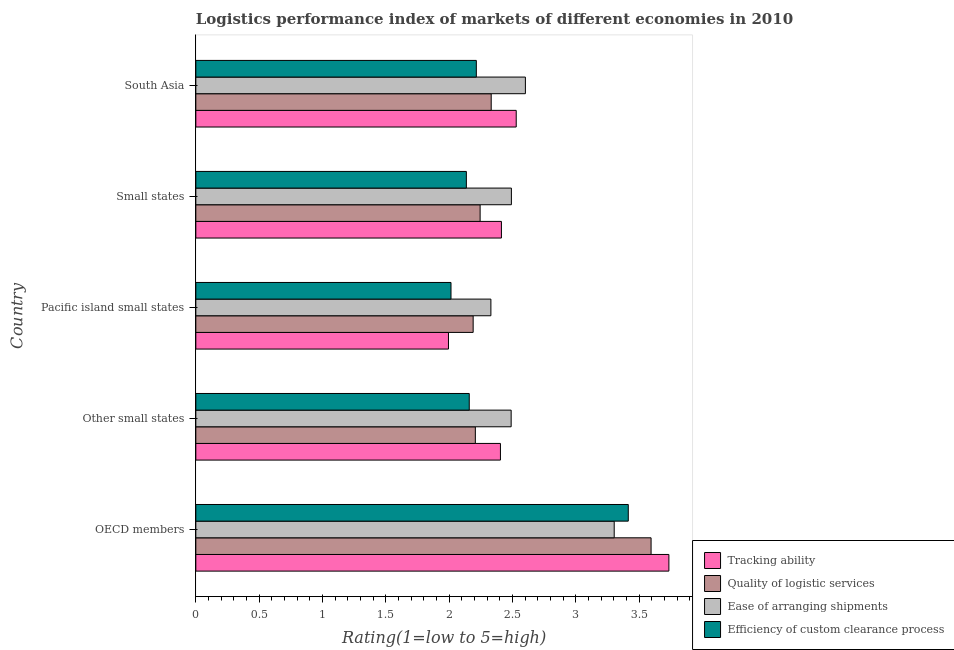How many groups of bars are there?
Your response must be concise. 5. Are the number of bars per tick equal to the number of legend labels?
Your answer should be very brief. Yes. What is the label of the 2nd group of bars from the top?
Give a very brief answer. Small states. What is the lpi rating of tracking ability in Pacific island small states?
Offer a terse response. 2. Across all countries, what is the maximum lpi rating of efficiency of custom clearance process?
Offer a very short reply. 3.42. Across all countries, what is the minimum lpi rating of ease of arranging shipments?
Keep it short and to the point. 2.33. In which country was the lpi rating of ease of arranging shipments maximum?
Keep it short and to the point. OECD members. In which country was the lpi rating of tracking ability minimum?
Offer a very short reply. Pacific island small states. What is the total lpi rating of efficiency of custom clearance process in the graph?
Give a very brief answer. 11.94. What is the difference between the lpi rating of ease of arranging shipments in Small states and that in South Asia?
Your answer should be compact. -0.11. What is the difference between the lpi rating of quality of logistic services in Pacific island small states and the lpi rating of efficiency of custom clearance process in Small states?
Keep it short and to the point. 0.05. What is the average lpi rating of efficiency of custom clearance process per country?
Keep it short and to the point. 2.39. What is the difference between the lpi rating of tracking ability and lpi rating of ease of arranging shipments in Pacific island small states?
Give a very brief answer. -0.34. In how many countries, is the lpi rating of quality of logistic services greater than 2.5 ?
Your answer should be very brief. 1. What is the ratio of the lpi rating of quality of logistic services in Other small states to that in South Asia?
Give a very brief answer. 0.95. Is the lpi rating of tracking ability in Other small states less than that in South Asia?
Your response must be concise. Yes. Is the difference between the lpi rating of tracking ability in Other small states and South Asia greater than the difference between the lpi rating of quality of logistic services in Other small states and South Asia?
Make the answer very short. Yes. What is the difference between the highest and the second highest lpi rating of quality of logistic services?
Provide a short and direct response. 1.26. What is the difference between the highest and the lowest lpi rating of tracking ability?
Offer a terse response. 1.74. In how many countries, is the lpi rating of quality of logistic services greater than the average lpi rating of quality of logistic services taken over all countries?
Give a very brief answer. 1. Is it the case that in every country, the sum of the lpi rating of ease of arranging shipments and lpi rating of tracking ability is greater than the sum of lpi rating of efficiency of custom clearance process and lpi rating of quality of logistic services?
Keep it short and to the point. No. What does the 2nd bar from the top in OECD members represents?
Offer a very short reply. Ease of arranging shipments. What does the 1st bar from the bottom in Other small states represents?
Your answer should be very brief. Tracking ability. Are all the bars in the graph horizontal?
Your answer should be compact. Yes. How many countries are there in the graph?
Keep it short and to the point. 5. What is the difference between two consecutive major ticks on the X-axis?
Make the answer very short. 0.5. Are the values on the major ticks of X-axis written in scientific E-notation?
Provide a succinct answer. No. Does the graph contain any zero values?
Your answer should be very brief. No. How are the legend labels stacked?
Your answer should be very brief. Vertical. What is the title of the graph?
Your answer should be compact. Logistics performance index of markets of different economies in 2010. Does "Rule based governance" appear as one of the legend labels in the graph?
Your answer should be very brief. No. What is the label or title of the X-axis?
Give a very brief answer. Rating(1=low to 5=high). What is the label or title of the Y-axis?
Offer a very short reply. Country. What is the Rating(1=low to 5=high) of Tracking ability in OECD members?
Make the answer very short. 3.74. What is the Rating(1=low to 5=high) of Quality of logistic services in OECD members?
Keep it short and to the point. 3.6. What is the Rating(1=low to 5=high) of Ease of arranging shipments in OECD members?
Offer a terse response. 3.3. What is the Rating(1=low to 5=high) in Efficiency of custom clearance process in OECD members?
Offer a terse response. 3.42. What is the Rating(1=low to 5=high) in Tracking ability in Other small states?
Provide a succinct answer. 2.41. What is the Rating(1=low to 5=high) of Quality of logistic services in Other small states?
Keep it short and to the point. 2.21. What is the Rating(1=low to 5=high) of Ease of arranging shipments in Other small states?
Provide a short and direct response. 2.49. What is the Rating(1=low to 5=high) of Efficiency of custom clearance process in Other small states?
Your answer should be compact. 2.16. What is the Rating(1=low to 5=high) of Tracking ability in Pacific island small states?
Your answer should be compact. 2. What is the Rating(1=low to 5=high) in Quality of logistic services in Pacific island small states?
Offer a very short reply. 2.19. What is the Rating(1=low to 5=high) of Ease of arranging shipments in Pacific island small states?
Offer a terse response. 2.33. What is the Rating(1=low to 5=high) of Efficiency of custom clearance process in Pacific island small states?
Your answer should be compact. 2.02. What is the Rating(1=low to 5=high) in Tracking ability in Small states?
Keep it short and to the point. 2.41. What is the Rating(1=low to 5=high) of Quality of logistic services in Small states?
Your response must be concise. 2.25. What is the Rating(1=low to 5=high) of Ease of arranging shipments in Small states?
Make the answer very short. 2.49. What is the Rating(1=low to 5=high) of Efficiency of custom clearance process in Small states?
Provide a succinct answer. 2.14. What is the Rating(1=low to 5=high) in Tracking ability in South Asia?
Your answer should be very brief. 2.53. What is the Rating(1=low to 5=high) of Quality of logistic services in South Asia?
Provide a short and direct response. 2.33. What is the Rating(1=low to 5=high) of Ease of arranging shipments in South Asia?
Give a very brief answer. 2.6. What is the Rating(1=low to 5=high) in Efficiency of custom clearance process in South Asia?
Offer a terse response. 2.21. Across all countries, what is the maximum Rating(1=low to 5=high) of Tracking ability?
Make the answer very short. 3.74. Across all countries, what is the maximum Rating(1=low to 5=high) in Quality of logistic services?
Keep it short and to the point. 3.6. Across all countries, what is the maximum Rating(1=low to 5=high) of Ease of arranging shipments?
Your answer should be very brief. 3.3. Across all countries, what is the maximum Rating(1=low to 5=high) in Efficiency of custom clearance process?
Your answer should be compact. 3.42. Across all countries, what is the minimum Rating(1=low to 5=high) in Tracking ability?
Ensure brevity in your answer.  2. Across all countries, what is the minimum Rating(1=low to 5=high) of Quality of logistic services?
Your answer should be very brief. 2.19. Across all countries, what is the minimum Rating(1=low to 5=high) of Ease of arranging shipments?
Provide a short and direct response. 2.33. Across all countries, what is the minimum Rating(1=low to 5=high) in Efficiency of custom clearance process?
Your response must be concise. 2.02. What is the total Rating(1=low to 5=high) in Tracking ability in the graph?
Keep it short and to the point. 13.08. What is the total Rating(1=low to 5=high) in Quality of logistic services in the graph?
Offer a very short reply. 12.57. What is the total Rating(1=low to 5=high) of Ease of arranging shipments in the graph?
Your response must be concise. 13.22. What is the total Rating(1=low to 5=high) in Efficiency of custom clearance process in the graph?
Keep it short and to the point. 11.94. What is the difference between the Rating(1=low to 5=high) of Tracking ability in OECD members and that in Other small states?
Ensure brevity in your answer.  1.33. What is the difference between the Rating(1=low to 5=high) in Quality of logistic services in OECD members and that in Other small states?
Provide a short and direct response. 1.39. What is the difference between the Rating(1=low to 5=high) in Ease of arranging shipments in OECD members and that in Other small states?
Provide a succinct answer. 0.81. What is the difference between the Rating(1=low to 5=high) of Efficiency of custom clearance process in OECD members and that in Other small states?
Ensure brevity in your answer.  1.26. What is the difference between the Rating(1=low to 5=high) in Tracking ability in OECD members and that in Pacific island small states?
Provide a succinct answer. 1.74. What is the difference between the Rating(1=low to 5=high) in Quality of logistic services in OECD members and that in Pacific island small states?
Your answer should be compact. 1.41. What is the difference between the Rating(1=low to 5=high) of Ease of arranging shipments in OECD members and that in Pacific island small states?
Offer a very short reply. 0.97. What is the difference between the Rating(1=low to 5=high) of Tracking ability in OECD members and that in Small states?
Ensure brevity in your answer.  1.32. What is the difference between the Rating(1=low to 5=high) of Quality of logistic services in OECD members and that in Small states?
Your answer should be very brief. 1.35. What is the difference between the Rating(1=low to 5=high) in Ease of arranging shipments in OECD members and that in Small states?
Make the answer very short. 0.81. What is the difference between the Rating(1=low to 5=high) in Efficiency of custom clearance process in OECD members and that in Small states?
Give a very brief answer. 1.28. What is the difference between the Rating(1=low to 5=high) of Tracking ability in OECD members and that in South Asia?
Make the answer very short. 1.21. What is the difference between the Rating(1=low to 5=high) in Quality of logistic services in OECD members and that in South Asia?
Your answer should be very brief. 1.26. What is the difference between the Rating(1=low to 5=high) of Ease of arranging shipments in OECD members and that in South Asia?
Make the answer very short. 0.7. What is the difference between the Rating(1=low to 5=high) of Tracking ability in Other small states and that in Pacific island small states?
Offer a very short reply. 0.41. What is the difference between the Rating(1=low to 5=high) of Quality of logistic services in Other small states and that in Pacific island small states?
Offer a very short reply. 0.02. What is the difference between the Rating(1=low to 5=high) in Ease of arranging shipments in Other small states and that in Pacific island small states?
Provide a succinct answer. 0.16. What is the difference between the Rating(1=low to 5=high) in Efficiency of custom clearance process in Other small states and that in Pacific island small states?
Provide a short and direct response. 0.14. What is the difference between the Rating(1=low to 5=high) of Tracking ability in Other small states and that in Small states?
Offer a very short reply. -0.01. What is the difference between the Rating(1=low to 5=high) of Quality of logistic services in Other small states and that in Small states?
Provide a succinct answer. -0.04. What is the difference between the Rating(1=low to 5=high) of Ease of arranging shipments in Other small states and that in Small states?
Give a very brief answer. -0. What is the difference between the Rating(1=low to 5=high) in Efficiency of custom clearance process in Other small states and that in Small states?
Your answer should be very brief. 0.02. What is the difference between the Rating(1=low to 5=high) in Tracking ability in Other small states and that in South Asia?
Your response must be concise. -0.12. What is the difference between the Rating(1=low to 5=high) in Quality of logistic services in Other small states and that in South Asia?
Your answer should be very brief. -0.13. What is the difference between the Rating(1=low to 5=high) of Ease of arranging shipments in Other small states and that in South Asia?
Give a very brief answer. -0.11. What is the difference between the Rating(1=low to 5=high) in Efficiency of custom clearance process in Other small states and that in South Asia?
Your answer should be compact. -0.06. What is the difference between the Rating(1=low to 5=high) of Tracking ability in Pacific island small states and that in Small states?
Make the answer very short. -0.42. What is the difference between the Rating(1=low to 5=high) in Quality of logistic services in Pacific island small states and that in Small states?
Your response must be concise. -0.06. What is the difference between the Rating(1=low to 5=high) of Ease of arranging shipments in Pacific island small states and that in Small states?
Keep it short and to the point. -0.16. What is the difference between the Rating(1=low to 5=high) of Efficiency of custom clearance process in Pacific island small states and that in Small states?
Ensure brevity in your answer.  -0.12. What is the difference between the Rating(1=low to 5=high) of Tracking ability in Pacific island small states and that in South Asia?
Provide a short and direct response. -0.54. What is the difference between the Rating(1=low to 5=high) of Quality of logistic services in Pacific island small states and that in South Asia?
Your answer should be very brief. -0.14. What is the difference between the Rating(1=low to 5=high) of Ease of arranging shipments in Pacific island small states and that in South Asia?
Keep it short and to the point. -0.27. What is the difference between the Rating(1=low to 5=high) in Tracking ability in Small states and that in South Asia?
Provide a short and direct response. -0.12. What is the difference between the Rating(1=low to 5=high) of Quality of logistic services in Small states and that in South Asia?
Keep it short and to the point. -0.09. What is the difference between the Rating(1=low to 5=high) of Ease of arranging shipments in Small states and that in South Asia?
Your answer should be very brief. -0.11. What is the difference between the Rating(1=low to 5=high) of Efficiency of custom clearance process in Small states and that in South Asia?
Give a very brief answer. -0.08. What is the difference between the Rating(1=low to 5=high) in Tracking ability in OECD members and the Rating(1=low to 5=high) in Quality of logistic services in Other small states?
Your answer should be compact. 1.53. What is the difference between the Rating(1=low to 5=high) of Tracking ability in OECD members and the Rating(1=low to 5=high) of Ease of arranging shipments in Other small states?
Give a very brief answer. 1.25. What is the difference between the Rating(1=low to 5=high) of Tracking ability in OECD members and the Rating(1=low to 5=high) of Efficiency of custom clearance process in Other small states?
Make the answer very short. 1.58. What is the difference between the Rating(1=low to 5=high) of Quality of logistic services in OECD members and the Rating(1=low to 5=high) of Ease of arranging shipments in Other small states?
Provide a short and direct response. 1.1. What is the difference between the Rating(1=low to 5=high) of Quality of logistic services in OECD members and the Rating(1=low to 5=high) of Efficiency of custom clearance process in Other small states?
Offer a very short reply. 1.44. What is the difference between the Rating(1=low to 5=high) of Ease of arranging shipments in OECD members and the Rating(1=low to 5=high) of Efficiency of custom clearance process in Other small states?
Offer a terse response. 1.14. What is the difference between the Rating(1=low to 5=high) of Tracking ability in OECD members and the Rating(1=low to 5=high) of Quality of logistic services in Pacific island small states?
Your response must be concise. 1.55. What is the difference between the Rating(1=low to 5=high) in Tracking ability in OECD members and the Rating(1=low to 5=high) in Ease of arranging shipments in Pacific island small states?
Provide a short and direct response. 1.41. What is the difference between the Rating(1=low to 5=high) of Tracking ability in OECD members and the Rating(1=low to 5=high) of Efficiency of custom clearance process in Pacific island small states?
Your answer should be very brief. 1.72. What is the difference between the Rating(1=low to 5=high) in Quality of logistic services in OECD members and the Rating(1=low to 5=high) in Ease of arranging shipments in Pacific island small states?
Your response must be concise. 1.26. What is the difference between the Rating(1=low to 5=high) of Quality of logistic services in OECD members and the Rating(1=low to 5=high) of Efficiency of custom clearance process in Pacific island small states?
Your answer should be very brief. 1.58. What is the difference between the Rating(1=low to 5=high) in Ease of arranging shipments in OECD members and the Rating(1=low to 5=high) in Efficiency of custom clearance process in Pacific island small states?
Provide a succinct answer. 1.29. What is the difference between the Rating(1=low to 5=high) in Tracking ability in OECD members and the Rating(1=low to 5=high) in Quality of logistic services in Small states?
Your response must be concise. 1.49. What is the difference between the Rating(1=low to 5=high) in Tracking ability in OECD members and the Rating(1=low to 5=high) in Ease of arranging shipments in Small states?
Ensure brevity in your answer.  1.24. What is the difference between the Rating(1=low to 5=high) in Tracking ability in OECD members and the Rating(1=low to 5=high) in Efficiency of custom clearance process in Small states?
Your answer should be compact. 1.6. What is the difference between the Rating(1=low to 5=high) of Quality of logistic services in OECD members and the Rating(1=low to 5=high) of Ease of arranging shipments in Small states?
Keep it short and to the point. 1.1. What is the difference between the Rating(1=low to 5=high) of Quality of logistic services in OECD members and the Rating(1=low to 5=high) of Efficiency of custom clearance process in Small states?
Offer a very short reply. 1.46. What is the difference between the Rating(1=low to 5=high) of Ease of arranging shipments in OECD members and the Rating(1=low to 5=high) of Efficiency of custom clearance process in Small states?
Provide a succinct answer. 1.17. What is the difference between the Rating(1=low to 5=high) of Tracking ability in OECD members and the Rating(1=low to 5=high) of Quality of logistic services in South Asia?
Ensure brevity in your answer.  1.4. What is the difference between the Rating(1=low to 5=high) in Tracking ability in OECD members and the Rating(1=low to 5=high) in Ease of arranging shipments in South Asia?
Offer a very short reply. 1.13. What is the difference between the Rating(1=low to 5=high) in Tracking ability in OECD members and the Rating(1=low to 5=high) in Efficiency of custom clearance process in South Asia?
Your response must be concise. 1.52. What is the difference between the Rating(1=low to 5=high) of Quality of logistic services in OECD members and the Rating(1=low to 5=high) of Efficiency of custom clearance process in South Asia?
Offer a very short reply. 1.38. What is the difference between the Rating(1=low to 5=high) in Ease of arranging shipments in OECD members and the Rating(1=low to 5=high) in Efficiency of custom clearance process in South Asia?
Offer a terse response. 1.09. What is the difference between the Rating(1=low to 5=high) in Tracking ability in Other small states and the Rating(1=low to 5=high) in Quality of logistic services in Pacific island small states?
Keep it short and to the point. 0.22. What is the difference between the Rating(1=low to 5=high) in Tracking ability in Other small states and the Rating(1=low to 5=high) in Ease of arranging shipments in Pacific island small states?
Your response must be concise. 0.08. What is the difference between the Rating(1=low to 5=high) in Tracking ability in Other small states and the Rating(1=low to 5=high) in Efficiency of custom clearance process in Pacific island small states?
Offer a terse response. 0.39. What is the difference between the Rating(1=low to 5=high) of Quality of logistic services in Other small states and the Rating(1=low to 5=high) of Ease of arranging shipments in Pacific island small states?
Your response must be concise. -0.12. What is the difference between the Rating(1=low to 5=high) of Quality of logistic services in Other small states and the Rating(1=low to 5=high) of Efficiency of custom clearance process in Pacific island small states?
Make the answer very short. 0.19. What is the difference between the Rating(1=low to 5=high) in Ease of arranging shipments in Other small states and the Rating(1=low to 5=high) in Efficiency of custom clearance process in Pacific island small states?
Provide a short and direct response. 0.47. What is the difference between the Rating(1=low to 5=high) of Tracking ability in Other small states and the Rating(1=low to 5=high) of Quality of logistic services in Small states?
Give a very brief answer. 0.16. What is the difference between the Rating(1=low to 5=high) in Tracking ability in Other small states and the Rating(1=low to 5=high) in Ease of arranging shipments in Small states?
Your answer should be compact. -0.09. What is the difference between the Rating(1=low to 5=high) in Tracking ability in Other small states and the Rating(1=low to 5=high) in Efficiency of custom clearance process in Small states?
Keep it short and to the point. 0.27. What is the difference between the Rating(1=low to 5=high) of Quality of logistic services in Other small states and the Rating(1=low to 5=high) of Ease of arranging shipments in Small states?
Provide a short and direct response. -0.28. What is the difference between the Rating(1=low to 5=high) in Quality of logistic services in Other small states and the Rating(1=low to 5=high) in Efficiency of custom clearance process in Small states?
Provide a succinct answer. 0.07. What is the difference between the Rating(1=low to 5=high) of Ease of arranging shipments in Other small states and the Rating(1=low to 5=high) of Efficiency of custom clearance process in Small states?
Make the answer very short. 0.35. What is the difference between the Rating(1=low to 5=high) of Tracking ability in Other small states and the Rating(1=low to 5=high) of Quality of logistic services in South Asia?
Offer a very short reply. 0.07. What is the difference between the Rating(1=low to 5=high) of Tracking ability in Other small states and the Rating(1=low to 5=high) of Ease of arranging shipments in South Asia?
Ensure brevity in your answer.  -0.2. What is the difference between the Rating(1=low to 5=high) in Tracking ability in Other small states and the Rating(1=low to 5=high) in Efficiency of custom clearance process in South Asia?
Provide a short and direct response. 0.19. What is the difference between the Rating(1=low to 5=high) in Quality of logistic services in Other small states and the Rating(1=low to 5=high) in Ease of arranging shipments in South Asia?
Your response must be concise. -0.4. What is the difference between the Rating(1=low to 5=high) in Quality of logistic services in Other small states and the Rating(1=low to 5=high) in Efficiency of custom clearance process in South Asia?
Give a very brief answer. -0.01. What is the difference between the Rating(1=low to 5=high) in Ease of arranging shipments in Other small states and the Rating(1=low to 5=high) in Efficiency of custom clearance process in South Asia?
Keep it short and to the point. 0.28. What is the difference between the Rating(1=low to 5=high) in Tracking ability in Pacific island small states and the Rating(1=low to 5=high) in Ease of arranging shipments in Small states?
Your answer should be compact. -0.5. What is the difference between the Rating(1=low to 5=high) of Tracking ability in Pacific island small states and the Rating(1=low to 5=high) of Efficiency of custom clearance process in Small states?
Offer a terse response. -0.14. What is the difference between the Rating(1=low to 5=high) in Quality of logistic services in Pacific island small states and the Rating(1=low to 5=high) in Ease of arranging shipments in Small states?
Offer a terse response. -0.3. What is the difference between the Rating(1=low to 5=high) in Quality of logistic services in Pacific island small states and the Rating(1=low to 5=high) in Efficiency of custom clearance process in Small states?
Provide a short and direct response. 0.05. What is the difference between the Rating(1=low to 5=high) in Ease of arranging shipments in Pacific island small states and the Rating(1=low to 5=high) in Efficiency of custom clearance process in Small states?
Provide a short and direct response. 0.19. What is the difference between the Rating(1=low to 5=high) of Tracking ability in Pacific island small states and the Rating(1=low to 5=high) of Quality of logistic services in South Asia?
Give a very brief answer. -0.34. What is the difference between the Rating(1=low to 5=high) in Tracking ability in Pacific island small states and the Rating(1=low to 5=high) in Ease of arranging shipments in South Asia?
Your answer should be very brief. -0.61. What is the difference between the Rating(1=low to 5=high) in Tracking ability in Pacific island small states and the Rating(1=low to 5=high) in Efficiency of custom clearance process in South Asia?
Your answer should be compact. -0.22. What is the difference between the Rating(1=low to 5=high) of Quality of logistic services in Pacific island small states and the Rating(1=low to 5=high) of Ease of arranging shipments in South Asia?
Your answer should be compact. -0.41. What is the difference between the Rating(1=low to 5=high) of Quality of logistic services in Pacific island small states and the Rating(1=low to 5=high) of Efficiency of custom clearance process in South Asia?
Offer a terse response. -0.03. What is the difference between the Rating(1=low to 5=high) of Ease of arranging shipments in Pacific island small states and the Rating(1=low to 5=high) of Efficiency of custom clearance process in South Asia?
Keep it short and to the point. 0.12. What is the difference between the Rating(1=low to 5=high) in Tracking ability in Small states and the Rating(1=low to 5=high) in Quality of logistic services in South Asia?
Your answer should be compact. 0.08. What is the difference between the Rating(1=low to 5=high) in Tracking ability in Small states and the Rating(1=low to 5=high) in Ease of arranging shipments in South Asia?
Offer a very short reply. -0.19. What is the difference between the Rating(1=low to 5=high) in Tracking ability in Small states and the Rating(1=low to 5=high) in Efficiency of custom clearance process in South Asia?
Keep it short and to the point. 0.2. What is the difference between the Rating(1=low to 5=high) of Quality of logistic services in Small states and the Rating(1=low to 5=high) of Ease of arranging shipments in South Asia?
Give a very brief answer. -0.36. What is the difference between the Rating(1=low to 5=high) in Quality of logistic services in Small states and the Rating(1=low to 5=high) in Efficiency of custom clearance process in South Asia?
Offer a very short reply. 0.03. What is the difference between the Rating(1=low to 5=high) in Ease of arranging shipments in Small states and the Rating(1=low to 5=high) in Efficiency of custom clearance process in South Asia?
Give a very brief answer. 0.28. What is the average Rating(1=low to 5=high) of Tracking ability per country?
Make the answer very short. 2.62. What is the average Rating(1=low to 5=high) in Quality of logistic services per country?
Provide a short and direct response. 2.51. What is the average Rating(1=low to 5=high) of Ease of arranging shipments per country?
Your answer should be very brief. 2.64. What is the average Rating(1=low to 5=high) in Efficiency of custom clearance process per country?
Offer a very short reply. 2.39. What is the difference between the Rating(1=low to 5=high) of Tracking ability and Rating(1=low to 5=high) of Quality of logistic services in OECD members?
Provide a short and direct response. 0.14. What is the difference between the Rating(1=low to 5=high) in Tracking ability and Rating(1=low to 5=high) in Ease of arranging shipments in OECD members?
Give a very brief answer. 0.43. What is the difference between the Rating(1=low to 5=high) in Tracking ability and Rating(1=low to 5=high) in Efficiency of custom clearance process in OECD members?
Offer a terse response. 0.32. What is the difference between the Rating(1=low to 5=high) in Quality of logistic services and Rating(1=low to 5=high) in Ease of arranging shipments in OECD members?
Your response must be concise. 0.29. What is the difference between the Rating(1=low to 5=high) in Quality of logistic services and Rating(1=low to 5=high) in Efficiency of custom clearance process in OECD members?
Your answer should be compact. 0.18. What is the difference between the Rating(1=low to 5=high) in Ease of arranging shipments and Rating(1=low to 5=high) in Efficiency of custom clearance process in OECD members?
Provide a short and direct response. -0.11. What is the difference between the Rating(1=low to 5=high) of Tracking ability and Rating(1=low to 5=high) of Quality of logistic services in Other small states?
Ensure brevity in your answer.  0.2. What is the difference between the Rating(1=low to 5=high) of Tracking ability and Rating(1=low to 5=high) of Ease of arranging shipments in Other small states?
Your response must be concise. -0.08. What is the difference between the Rating(1=low to 5=high) of Tracking ability and Rating(1=low to 5=high) of Efficiency of custom clearance process in Other small states?
Give a very brief answer. 0.25. What is the difference between the Rating(1=low to 5=high) in Quality of logistic services and Rating(1=low to 5=high) in Ease of arranging shipments in Other small states?
Give a very brief answer. -0.28. What is the difference between the Rating(1=low to 5=high) of Quality of logistic services and Rating(1=low to 5=high) of Efficiency of custom clearance process in Other small states?
Provide a short and direct response. 0.05. What is the difference between the Rating(1=low to 5=high) in Ease of arranging shipments and Rating(1=low to 5=high) in Efficiency of custom clearance process in Other small states?
Provide a succinct answer. 0.33. What is the difference between the Rating(1=low to 5=high) in Tracking ability and Rating(1=low to 5=high) in Quality of logistic services in Pacific island small states?
Offer a terse response. -0.2. What is the difference between the Rating(1=low to 5=high) in Tracking ability and Rating(1=low to 5=high) in Ease of arranging shipments in Pacific island small states?
Ensure brevity in your answer.  -0.34. What is the difference between the Rating(1=low to 5=high) in Tracking ability and Rating(1=low to 5=high) in Efficiency of custom clearance process in Pacific island small states?
Give a very brief answer. -0.02. What is the difference between the Rating(1=low to 5=high) of Quality of logistic services and Rating(1=low to 5=high) of Ease of arranging shipments in Pacific island small states?
Your response must be concise. -0.14. What is the difference between the Rating(1=low to 5=high) of Quality of logistic services and Rating(1=low to 5=high) of Efficiency of custom clearance process in Pacific island small states?
Offer a terse response. 0.17. What is the difference between the Rating(1=low to 5=high) of Ease of arranging shipments and Rating(1=low to 5=high) of Efficiency of custom clearance process in Pacific island small states?
Give a very brief answer. 0.32. What is the difference between the Rating(1=low to 5=high) of Tracking ability and Rating(1=low to 5=high) of Quality of logistic services in Small states?
Keep it short and to the point. 0.17. What is the difference between the Rating(1=low to 5=high) of Tracking ability and Rating(1=low to 5=high) of Ease of arranging shipments in Small states?
Keep it short and to the point. -0.08. What is the difference between the Rating(1=low to 5=high) in Tracking ability and Rating(1=low to 5=high) in Efficiency of custom clearance process in Small states?
Offer a terse response. 0.28. What is the difference between the Rating(1=low to 5=high) of Quality of logistic services and Rating(1=low to 5=high) of Ease of arranging shipments in Small states?
Keep it short and to the point. -0.25. What is the difference between the Rating(1=low to 5=high) of Quality of logistic services and Rating(1=low to 5=high) of Efficiency of custom clearance process in Small states?
Offer a very short reply. 0.11. What is the difference between the Rating(1=low to 5=high) of Ease of arranging shipments and Rating(1=low to 5=high) of Efficiency of custom clearance process in Small states?
Your answer should be compact. 0.36. What is the difference between the Rating(1=low to 5=high) of Tracking ability and Rating(1=low to 5=high) of Quality of logistic services in South Asia?
Keep it short and to the point. 0.2. What is the difference between the Rating(1=low to 5=high) in Tracking ability and Rating(1=low to 5=high) in Ease of arranging shipments in South Asia?
Keep it short and to the point. -0.07. What is the difference between the Rating(1=low to 5=high) of Tracking ability and Rating(1=low to 5=high) of Efficiency of custom clearance process in South Asia?
Your answer should be very brief. 0.32. What is the difference between the Rating(1=low to 5=high) in Quality of logistic services and Rating(1=low to 5=high) in Ease of arranging shipments in South Asia?
Provide a succinct answer. -0.27. What is the difference between the Rating(1=low to 5=high) in Quality of logistic services and Rating(1=low to 5=high) in Efficiency of custom clearance process in South Asia?
Keep it short and to the point. 0.12. What is the difference between the Rating(1=low to 5=high) of Ease of arranging shipments and Rating(1=low to 5=high) of Efficiency of custom clearance process in South Asia?
Provide a short and direct response. 0.39. What is the ratio of the Rating(1=low to 5=high) in Tracking ability in OECD members to that in Other small states?
Ensure brevity in your answer.  1.55. What is the ratio of the Rating(1=low to 5=high) of Quality of logistic services in OECD members to that in Other small states?
Offer a very short reply. 1.63. What is the ratio of the Rating(1=low to 5=high) of Ease of arranging shipments in OECD members to that in Other small states?
Provide a succinct answer. 1.33. What is the ratio of the Rating(1=low to 5=high) of Efficiency of custom clearance process in OECD members to that in Other small states?
Make the answer very short. 1.58. What is the ratio of the Rating(1=low to 5=high) of Tracking ability in OECD members to that in Pacific island small states?
Your answer should be compact. 1.87. What is the ratio of the Rating(1=low to 5=high) of Quality of logistic services in OECD members to that in Pacific island small states?
Keep it short and to the point. 1.64. What is the ratio of the Rating(1=low to 5=high) in Ease of arranging shipments in OECD members to that in Pacific island small states?
Your answer should be very brief. 1.42. What is the ratio of the Rating(1=low to 5=high) in Efficiency of custom clearance process in OECD members to that in Pacific island small states?
Give a very brief answer. 1.69. What is the ratio of the Rating(1=low to 5=high) of Tracking ability in OECD members to that in Small states?
Give a very brief answer. 1.55. What is the ratio of the Rating(1=low to 5=high) of Quality of logistic services in OECD members to that in Small states?
Provide a succinct answer. 1.6. What is the ratio of the Rating(1=low to 5=high) of Ease of arranging shipments in OECD members to that in Small states?
Offer a terse response. 1.33. What is the ratio of the Rating(1=low to 5=high) in Efficiency of custom clearance process in OECD members to that in Small states?
Offer a terse response. 1.6. What is the ratio of the Rating(1=low to 5=high) of Tracking ability in OECD members to that in South Asia?
Ensure brevity in your answer.  1.48. What is the ratio of the Rating(1=low to 5=high) of Quality of logistic services in OECD members to that in South Asia?
Make the answer very short. 1.54. What is the ratio of the Rating(1=low to 5=high) of Ease of arranging shipments in OECD members to that in South Asia?
Provide a succinct answer. 1.27. What is the ratio of the Rating(1=low to 5=high) of Efficiency of custom clearance process in OECD members to that in South Asia?
Provide a succinct answer. 1.54. What is the ratio of the Rating(1=low to 5=high) in Tracking ability in Other small states to that in Pacific island small states?
Provide a short and direct response. 1.21. What is the ratio of the Rating(1=low to 5=high) of Quality of logistic services in Other small states to that in Pacific island small states?
Keep it short and to the point. 1.01. What is the ratio of the Rating(1=low to 5=high) in Ease of arranging shipments in Other small states to that in Pacific island small states?
Your response must be concise. 1.07. What is the ratio of the Rating(1=low to 5=high) in Efficiency of custom clearance process in Other small states to that in Pacific island small states?
Give a very brief answer. 1.07. What is the ratio of the Rating(1=low to 5=high) in Tracking ability in Other small states to that in Small states?
Offer a terse response. 1. What is the ratio of the Rating(1=low to 5=high) of Quality of logistic services in Other small states to that in Small states?
Your response must be concise. 0.98. What is the ratio of the Rating(1=low to 5=high) of Efficiency of custom clearance process in Other small states to that in Small states?
Keep it short and to the point. 1.01. What is the ratio of the Rating(1=low to 5=high) of Tracking ability in Other small states to that in South Asia?
Give a very brief answer. 0.95. What is the ratio of the Rating(1=low to 5=high) in Quality of logistic services in Other small states to that in South Asia?
Your response must be concise. 0.95. What is the ratio of the Rating(1=low to 5=high) of Ease of arranging shipments in Other small states to that in South Asia?
Offer a very short reply. 0.96. What is the ratio of the Rating(1=low to 5=high) of Efficiency of custom clearance process in Other small states to that in South Asia?
Give a very brief answer. 0.97. What is the ratio of the Rating(1=low to 5=high) of Tracking ability in Pacific island small states to that in Small states?
Your answer should be compact. 0.83. What is the ratio of the Rating(1=low to 5=high) in Quality of logistic services in Pacific island small states to that in Small states?
Provide a short and direct response. 0.98. What is the ratio of the Rating(1=low to 5=high) of Ease of arranging shipments in Pacific island small states to that in Small states?
Your answer should be compact. 0.94. What is the ratio of the Rating(1=low to 5=high) of Efficiency of custom clearance process in Pacific island small states to that in Small states?
Offer a terse response. 0.94. What is the ratio of the Rating(1=low to 5=high) in Tracking ability in Pacific island small states to that in South Asia?
Your answer should be compact. 0.79. What is the ratio of the Rating(1=low to 5=high) of Quality of logistic services in Pacific island small states to that in South Asia?
Your answer should be compact. 0.94. What is the ratio of the Rating(1=low to 5=high) of Ease of arranging shipments in Pacific island small states to that in South Asia?
Your answer should be very brief. 0.9. What is the ratio of the Rating(1=low to 5=high) in Efficiency of custom clearance process in Pacific island small states to that in South Asia?
Ensure brevity in your answer.  0.91. What is the ratio of the Rating(1=low to 5=high) of Tracking ability in Small states to that in South Asia?
Keep it short and to the point. 0.95. What is the ratio of the Rating(1=low to 5=high) in Quality of logistic services in Small states to that in South Asia?
Provide a short and direct response. 0.96. What is the ratio of the Rating(1=low to 5=high) in Ease of arranging shipments in Small states to that in South Asia?
Offer a very short reply. 0.96. What is the ratio of the Rating(1=low to 5=high) in Efficiency of custom clearance process in Small states to that in South Asia?
Make the answer very short. 0.96. What is the difference between the highest and the second highest Rating(1=low to 5=high) in Tracking ability?
Give a very brief answer. 1.21. What is the difference between the highest and the second highest Rating(1=low to 5=high) of Quality of logistic services?
Give a very brief answer. 1.26. What is the difference between the highest and the second highest Rating(1=low to 5=high) in Ease of arranging shipments?
Offer a terse response. 0.7. What is the difference between the highest and the lowest Rating(1=low to 5=high) of Tracking ability?
Keep it short and to the point. 1.74. What is the difference between the highest and the lowest Rating(1=low to 5=high) in Quality of logistic services?
Offer a very short reply. 1.41. What is the difference between the highest and the lowest Rating(1=low to 5=high) of Ease of arranging shipments?
Provide a succinct answer. 0.97. What is the difference between the highest and the lowest Rating(1=low to 5=high) in Efficiency of custom clearance process?
Your answer should be compact. 1.4. 